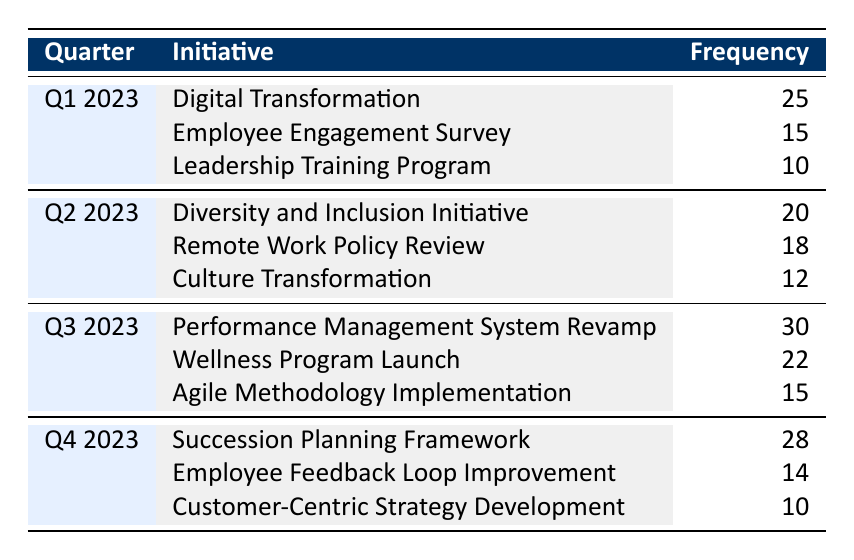What was the initiative with the highest frequency in Q3 2023? The table shows that in Q3 2023, the initiative with the highest frequency is "Performance Management System Revamp," which has a frequency of 30.
Answer: Performance Management System Revamp How many initiatives were implemented in Q2 2023? The table lists three initiatives for Q2 2023: "Diversity and Inclusion Initiative," "Remote Work Policy Review," and "Culture Transformation." Thus, there are three initiatives in total.
Answer: 3 What is the total frequency of initiatives in Q1 2023? To calculate the total frequency for Q1 2023, we add the frequencies of the three initiatives: 25 (Digital Transformation) + 15 (Employee Engagement Survey) + 10 (Leadership Training Program) = 50.
Answer: 50 Is the "Customer-Centric Strategy Development" initiative more prevalent than the "Employee Engagement Survey"? Comparing their frequencies, "Customer-Centric Strategy Development" has a frequency of 10, while "Employee Engagement Survey" has a frequency of 15. Since 10 is less than 15, the statement is false.
Answer: No What is the average frequency of initiatives in Q4 2023? The frequencies for Q4 2023 are 28 (Succession Planning Framework), 14 (Employee Feedback Loop Improvement), and 10 (Customer-Centric Strategy Development). The total frequency is 28 + 14 + 10 = 52, and there are 3 initiatives, so the average is 52 / 3 = 17.33.
Answer: 17.33 Which quarter had the least total frequency of initiatives and what was that frequency? Adding the frequencies for each quarter: Q1 has 50, Q2 has 50, Q3 has 67, and Q4 has 52. The least total frequency occurs in Q1 and Q2, both with 50.
Answer: 50 What initiative was implemented the least in Q2 2023? In Q2 2023, the initiatives and their frequencies are: 20 (Diversity and Inclusion Initiative), 18 (Remote Work Policy Review), and 12 (Culture Transformation). The least implemented initiative is "Culture Transformation," which has a frequency of 12.
Answer: Culture Transformation Was the "Wellness Program Launch" initiative more frequently implemented than the "Leadership Training Program"? The frequency of "Wellness Program Launch" is 22, and the frequency of "Leadership Training Program" is 10. Since 22 is greater than 10, the statement is true.
Answer: Yes 